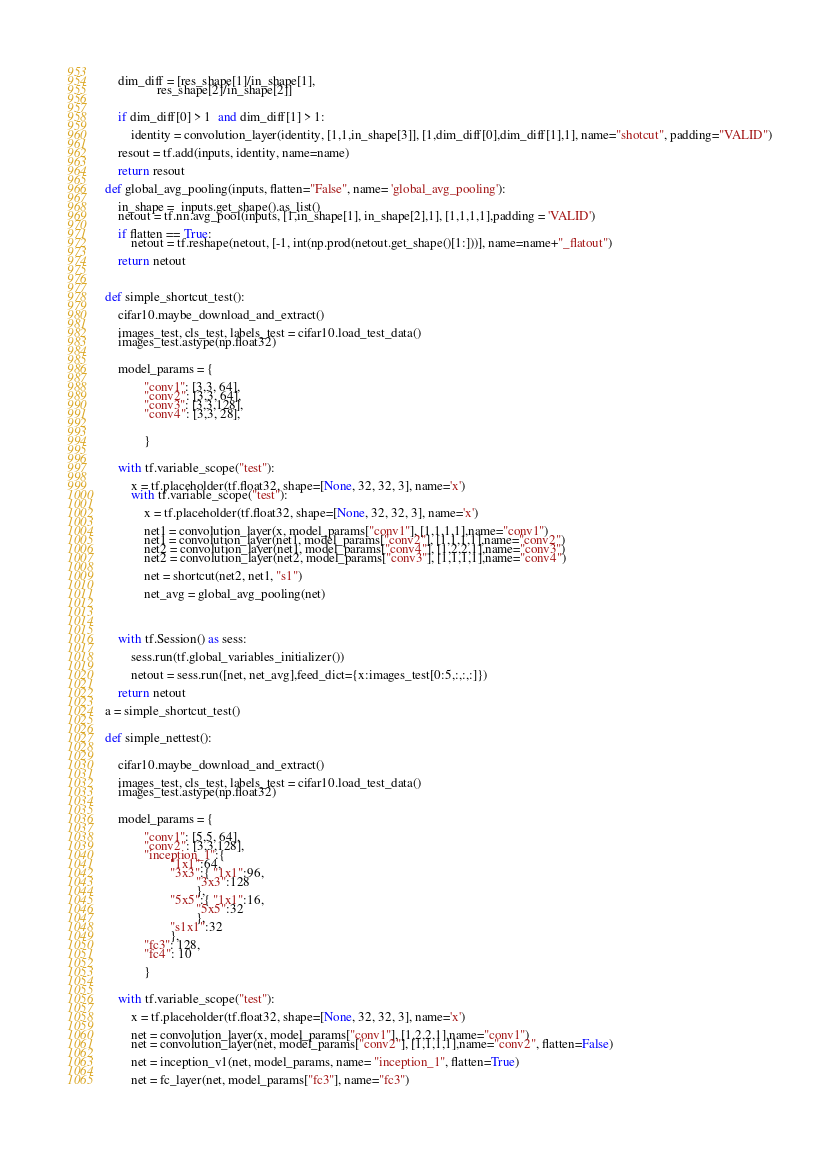Convert code to text. <code><loc_0><loc_0><loc_500><loc_500><_Python_>    
    dim_diff = [res_shape[1]/in_shape[1],
                res_shape[2]/in_shape[2]]
    
    
    if dim_diff[0] > 1  and dim_diff[1] > 1:
    
        identity = convolution_layer(identity, [1,1,in_shape[3]], [1,dim_diff[0],dim_diff[1],1], name="shotcut", padding="VALID")
    
    resout = tf.add(inputs, identity, name=name)
    
    return resout

def global_avg_pooling(inputs, flatten="False", name= 'global_avg_pooling'):
    
    in_shape =  inputs.get_shape().as_list()  
    netout = tf.nn.avg_pool(inputs, [1,in_shape[1], in_shape[2],1], [1,1,1,1],padding = 'VALID')
    
    if flatten == True:
        netout = tf.reshape(netout, [-1, int(np.prod(netout.get_shape()[1:]))], name=name+"_flatout")
        
    return netout
    
    

def simple_shortcut_test():
    
    cifar10.maybe_download_and_extract()
        
    images_test, cls_test, labels_test = cifar10.load_test_data()
    images_test.astype(np.float32)
    
    
    model_params = {
            
            "conv1": [3,3, 64],
            "conv2": [3,3, 64],
            "conv3": [3,3,128],
            "conv4": [3,3, 28],
            
            
            }
    
    
    with tf.variable_scope("test"):
        
        x = tf.placeholder(tf.float32, shape=[None, 32, 32, 3], name='x')
        with tf.variable_scope("test"):
            
            x = tf.placeholder(tf.float32, shape=[None, 32, 32, 3], name='x')
           
            net1 = convolution_layer(x, model_params["conv1"], [1,1,1,1],name="conv1")
            net1 = convolution_layer(net1, model_params["conv2"], [1,1,1,1],name="conv2")
            net2 = convolution_layer(net1, model_params["conv4"], [1,2,2,1],name="conv3")
            net2 = convolution_layer(net2, model_params["conv3"], [1,1,1,1],name="conv4")
            
            net = shortcut(net2, net1, "s1")
            
            net_avg = global_avg_pooling(net)
            
        
        
        
    with tf.Session() as sess:
        
        sess.run(tf.global_variables_initializer())
        
        netout = sess.run([net, net_avg],feed_dict={x:images_test[0:5,:,:,:]})
        
    return netout

a = simple_shortcut_test()     
        

def simple_nettest():

    
    cifar10.maybe_download_and_extract()
    
    images_test, cls_test, labels_test = cifar10.load_test_data()
    images_test.astype(np.float32)
    
    
    model_params = {
            
            "conv1": [5,5, 64],
            "conv2": [3,3,128],
            "inception_1":{                 
                    "1x1":64,
                    "3x3":{ "1x1":96,
                            "3x3":128
                            },
                    "5x5":{ "1x1":16,
                            "5x5":32
                            },
                    "s1x1":32
                    },
            "fc3": 128,
            "fc4": 10
            
            }
    
    
    with tf.variable_scope("test"):
        
        x = tf.placeholder(tf.float32, shape=[None, 32, 32, 3], name='x')
       
        net = convolution_layer(x, model_params["conv1"], [1,2,2,1],name="conv1")
        net = convolution_layer(net, model_params["conv2"], [1,1,1,1],name="conv2", flatten=False)
        
        net = inception_v1(net, model_params, name= "inception_1", flatten=True)
     
        net = fc_layer(net, model_params["fc3"], name="fc3")</code> 